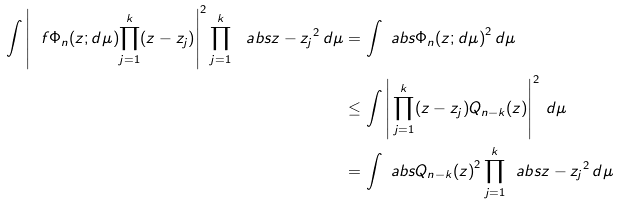<formula> <loc_0><loc_0><loc_500><loc_500>\int \left | \ f { \Phi _ { n } ( z ; d \mu ) } { \prod _ { j = 1 } ^ { k } ( z - z _ { j } ) } \right | ^ { 2 } \prod _ { j = 1 } ^ { k } \, \ a b s { z - z _ { j } } ^ { 2 } \, d \mu & = \int \ a b s { \Phi _ { n } ( z ; d \mu ) } ^ { 2 } \, d \mu \\ & \leq \int \left | \, \prod _ { j = 1 } ^ { k } ( z - z _ { j } ) Q _ { n - k } ( z ) \right | ^ { 2 } \, d \mu \\ & = \int \ a b s { Q _ { n - k } ( z ) } ^ { 2 } \prod _ { j = 1 } ^ { k } \, \ a b s { z - z _ { j } } ^ { 2 } \, d \mu</formula> 